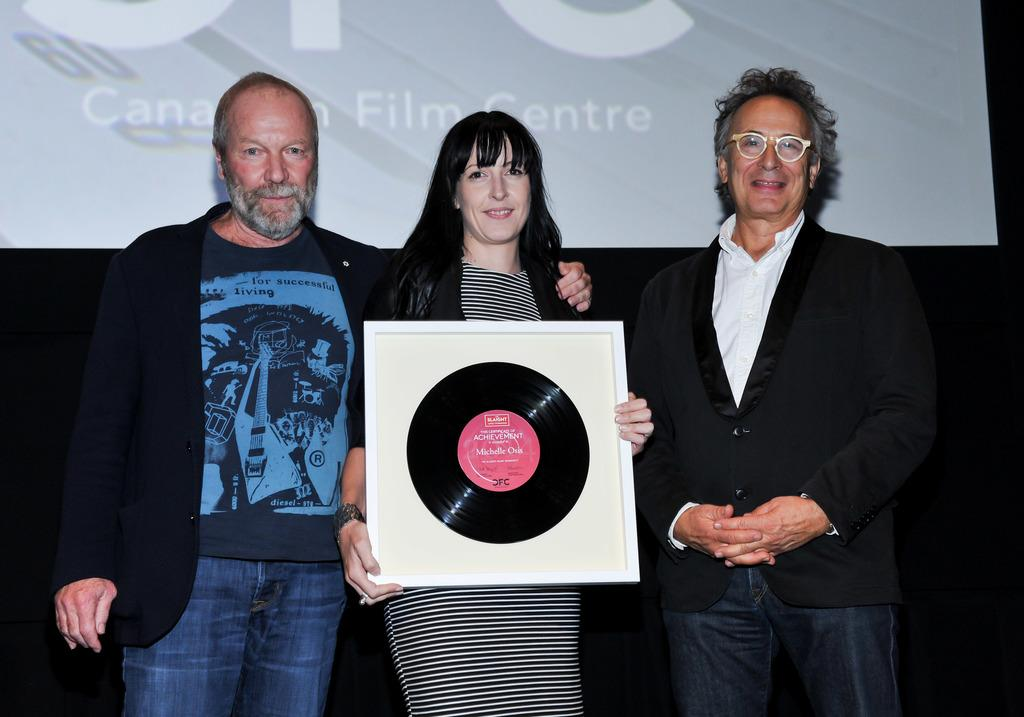How many people are present in the image? There are three people in the image. Can you describe what one of the people is doing? One woman is holding an object. What can be seen in the background of the image? There is a projector screen in the background of the image. What type of board is being used for the party in the image? There is no party or board present in the image. 